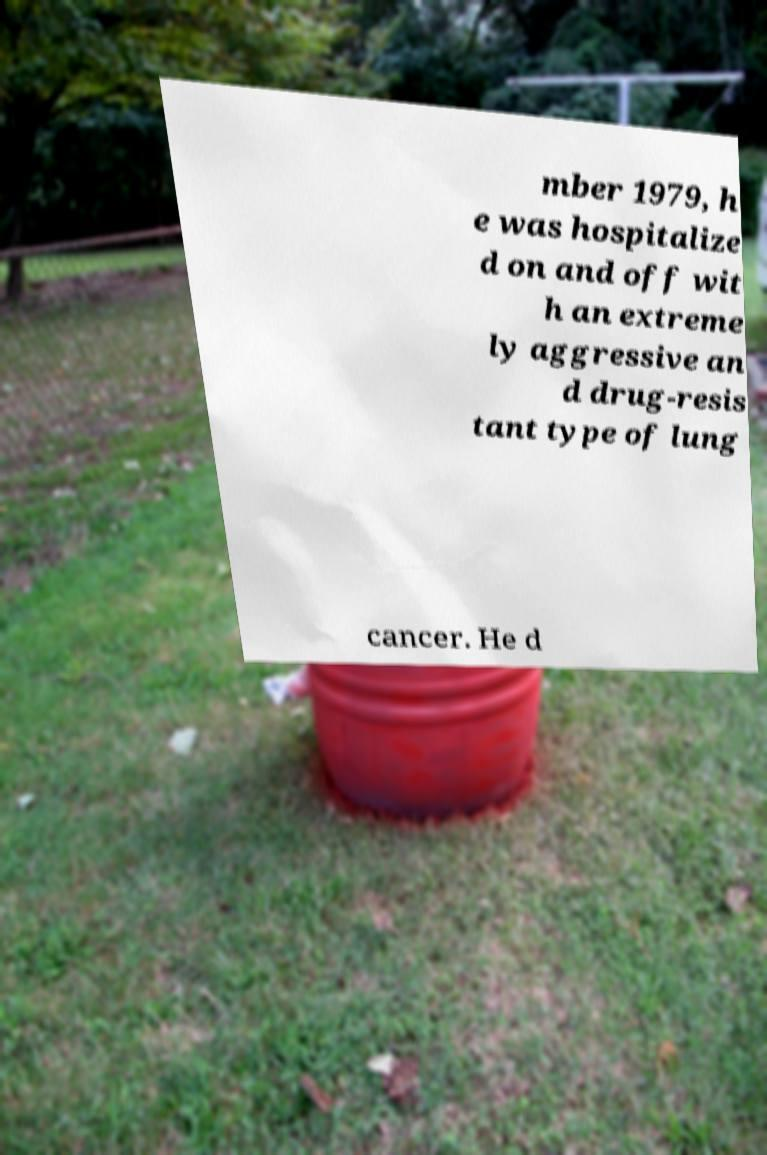Can you accurately transcribe the text from the provided image for me? mber 1979, h e was hospitalize d on and off wit h an extreme ly aggressive an d drug-resis tant type of lung cancer. He d 